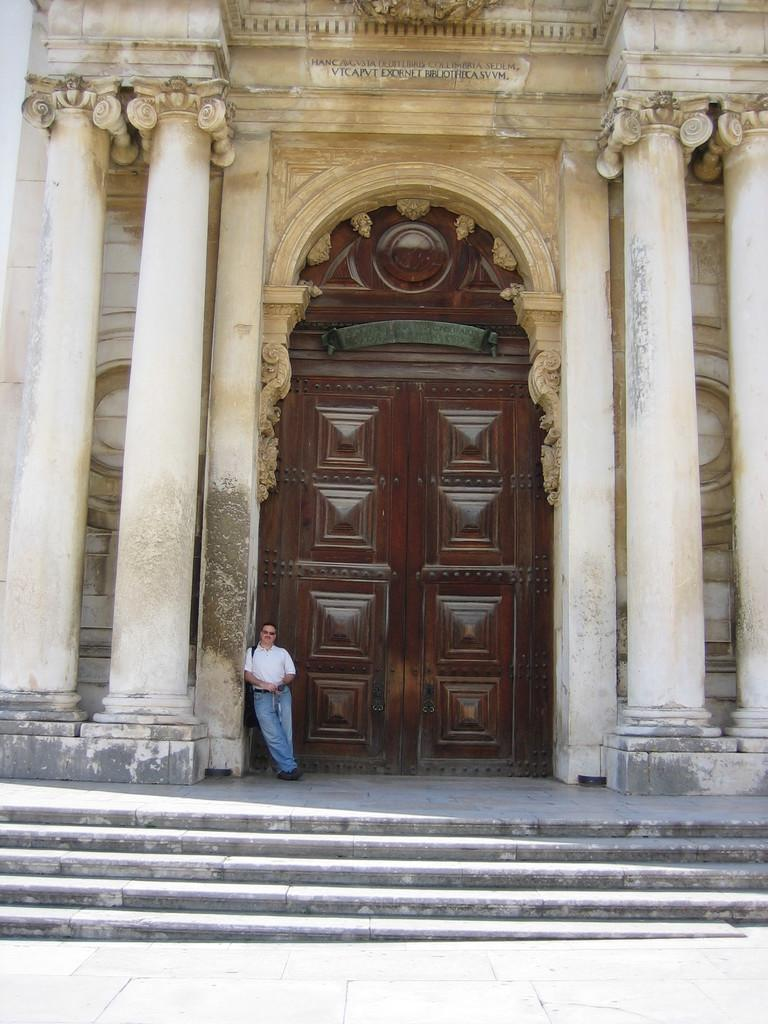What is the man in the image doing? The man is standing near the door in the image. What architectural features are present on the sides of the image? There are pillars on the right and left sides of the image. What is the purpose of the pillars in the image? The pillars are part of a building. What can be seen at the bottom of the image? There are stairs visible at the bottom of the image. What type of zinc structure can be seen in the image? There is no zinc structure present in the image. What is the man using to cook in the image? There is no pan or cooking activity present in the image. 